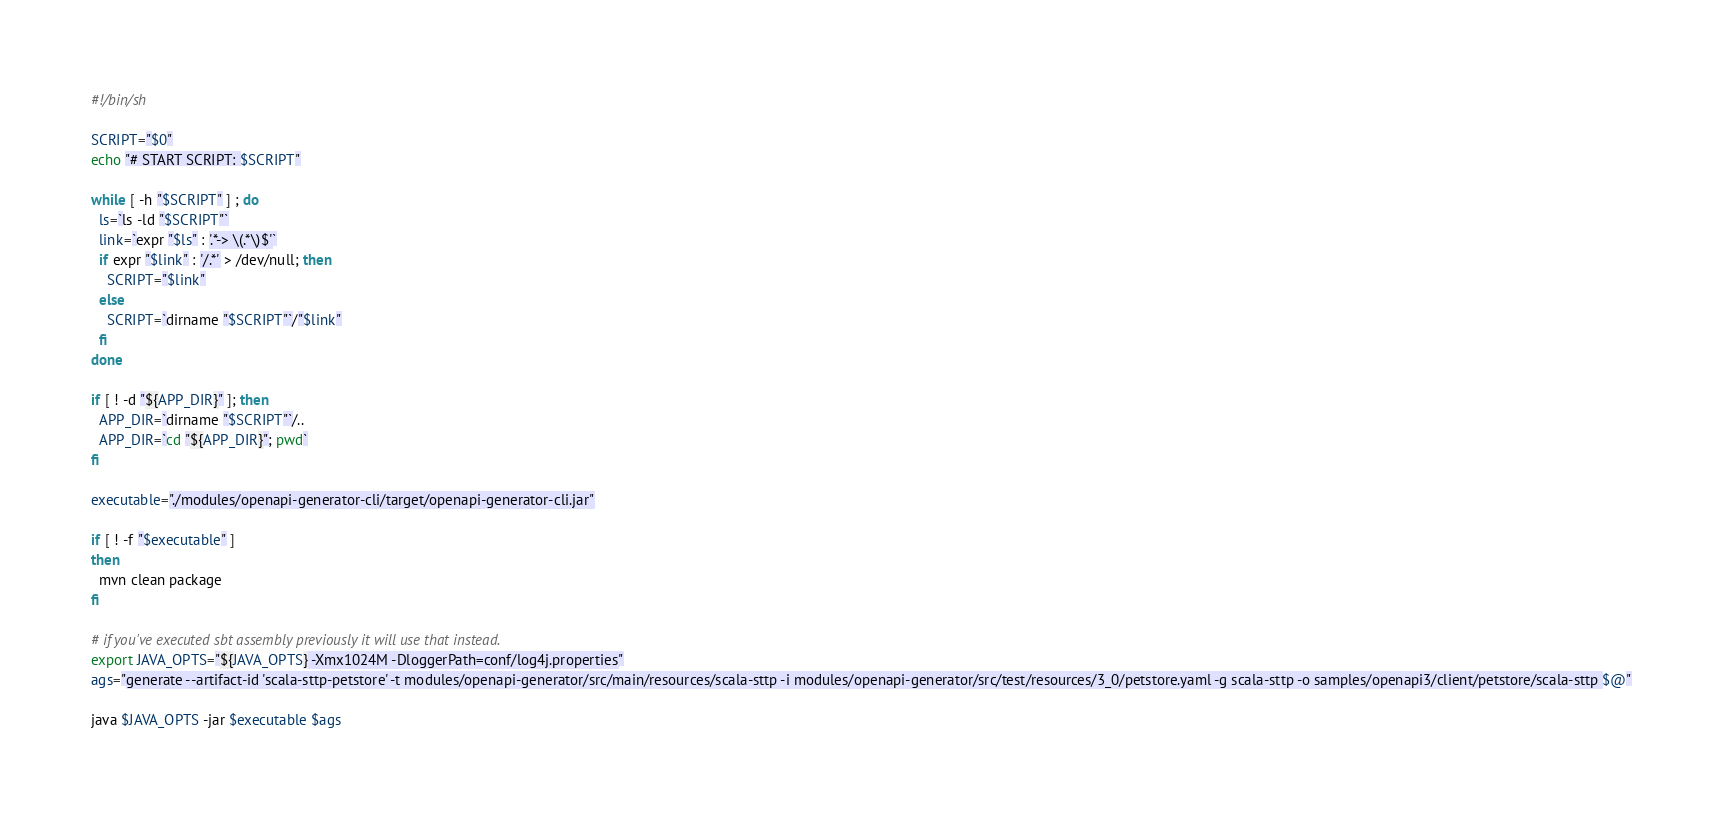Convert code to text. <code><loc_0><loc_0><loc_500><loc_500><_Bash_>#!/bin/sh

SCRIPT="$0"
echo "# START SCRIPT: $SCRIPT"

while [ -h "$SCRIPT" ] ; do
  ls=`ls -ld "$SCRIPT"`
  link=`expr "$ls" : '.*-> \(.*\)$'`
  if expr "$link" : '/.*' > /dev/null; then
    SCRIPT="$link"
  else
    SCRIPT=`dirname "$SCRIPT"`/"$link"
  fi
done

if [ ! -d "${APP_DIR}" ]; then
  APP_DIR=`dirname "$SCRIPT"`/..
  APP_DIR=`cd "${APP_DIR}"; pwd`
fi

executable="./modules/openapi-generator-cli/target/openapi-generator-cli.jar"

if [ ! -f "$executable" ]
then
  mvn clean package
fi

# if you've executed sbt assembly previously it will use that instead.
export JAVA_OPTS="${JAVA_OPTS} -Xmx1024M -DloggerPath=conf/log4j.properties"
ags="generate --artifact-id 'scala-sttp-petstore' -t modules/openapi-generator/src/main/resources/scala-sttp -i modules/openapi-generator/src/test/resources/3_0/petstore.yaml -g scala-sttp -o samples/openapi3/client/petstore/scala-sttp $@"

java $JAVA_OPTS -jar $executable $ags
</code> 